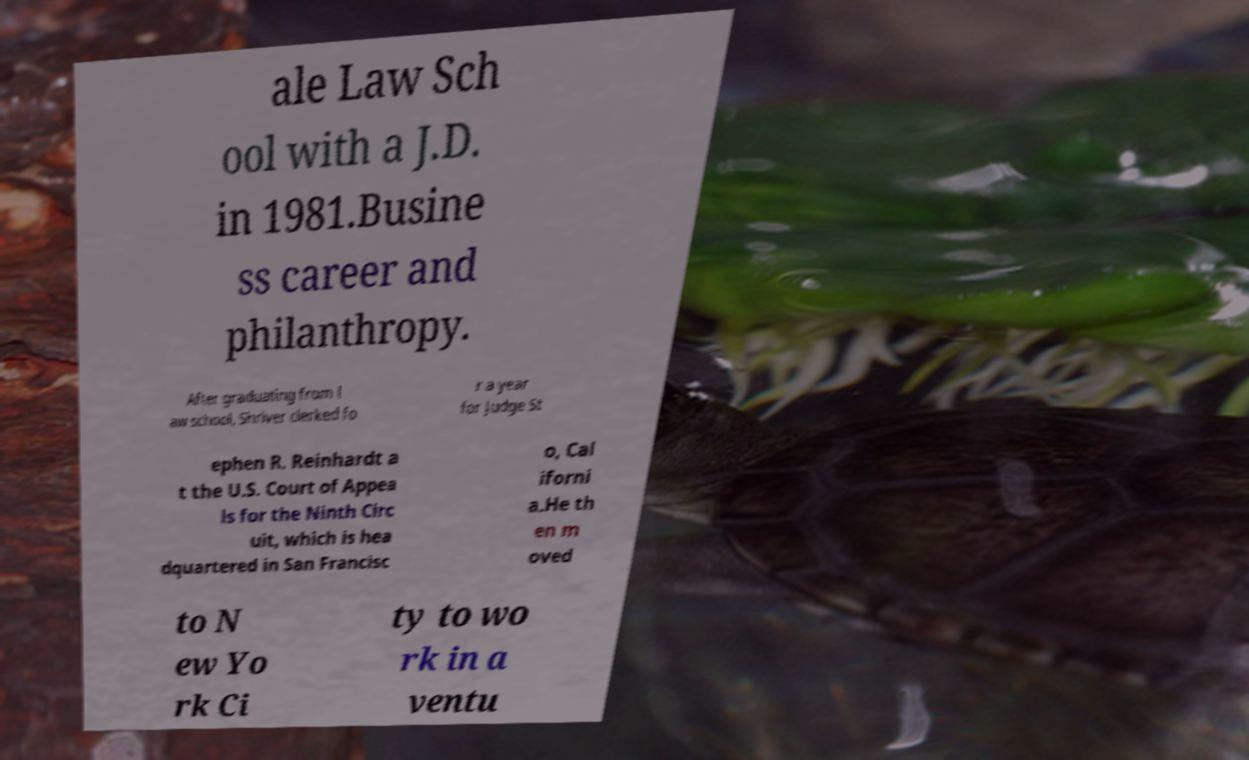Could you assist in decoding the text presented in this image and type it out clearly? ale Law Sch ool with a J.D. in 1981.Busine ss career and philanthropy. After graduating from l aw school, Shriver clerked fo r a year for Judge St ephen R. Reinhardt a t the U.S. Court of Appea ls for the Ninth Circ uit, which is hea dquartered in San Francisc o, Cal iforni a.He th en m oved to N ew Yo rk Ci ty to wo rk in a ventu 